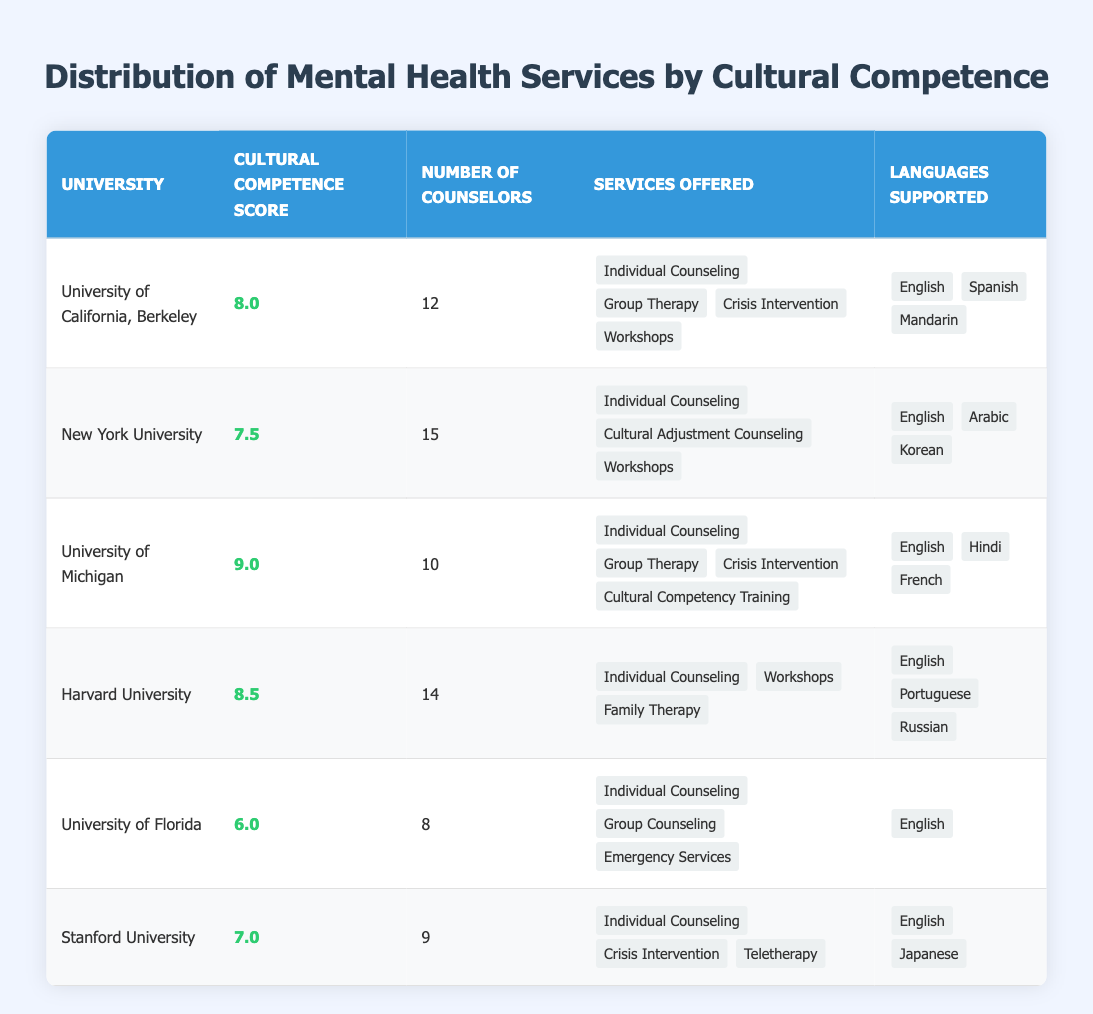What is the cultural competence score of Stanford University? The table shows a column labeled "Cultural Competence Score." By locating the row for Stanford University, I can see that the score listed next to it is 7.0.
Answer: 7.0 Which university has the highest number of counselors? I need to compare the "Number of Counselors" column across all universities. Upon reviewing the values, New York University has 15 counselors, which is the highest.
Answer: New York University What services are offered at the University of California, Berkeley? By looking at the row for the University of California, Berkeley in the table, I see the "Services Offered" column lists "Individual Counseling," "Group Therapy," "Crisis Intervention," and "Workshops."
Answer: Individual Counseling, Group Therapy, Crisis Intervention, Workshops Are there any universities that offer Family Therapy? I can check each row for the "Services Offered" column to see if any mention Family Therapy. Upon examination, I find that Harvard University offers Family Therapy, which makes it true.
Answer: Yes What is the average cultural competence score for all the universities listed? I first add the cultural competence scores from all universities: 8 + 7.5 + 9 + 8.5 + 6 + 7 = 46. The total number of universities is 6. Therefore, I divide 46 by 6 to find the average: 46 / 6 = 7.67.
Answer: 7.67 Which university or universities support the most languages? I will look at the "Languages Supported" column for each university and count the number of languages. The University of California, Berkeley supports 3 languages, New York University supports 3 languages, and the University of Michigan supports 3 languages. Thus, multiple universities support the most languages.
Answer: University of California, Berkeley; New York University; University of Michigan Is it true that the University of Florida scores higher than Stanford University in terms of cultural competence? I need to look at the "Cultural Competence Score" for both universities. The University of Florida has a score of 6.0, while Stanford University has a score of 7.0. Since 6.0 is not higher than 7.0, the statement is false.
Answer: No What is the difference between the number of counselors at the University of Michigan and the University of Florida? The University of Michigan has 10 counselors and the University of Florida has 8 counselors. To find the difference, I subtract the number of counselors at Florida from Michigan: 10 - 8 = 2.
Answer: 2 Which university has a cultural competence score of 8.5? By inspecting the "Cultural Competence Score" column, I find that Harvard University is the only university listed with a score of 8.5.
Answer: Harvard University 